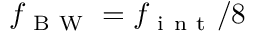<formula> <loc_0><loc_0><loc_500><loc_500>f _ { B W } = f _ { i n t } / 8</formula> 